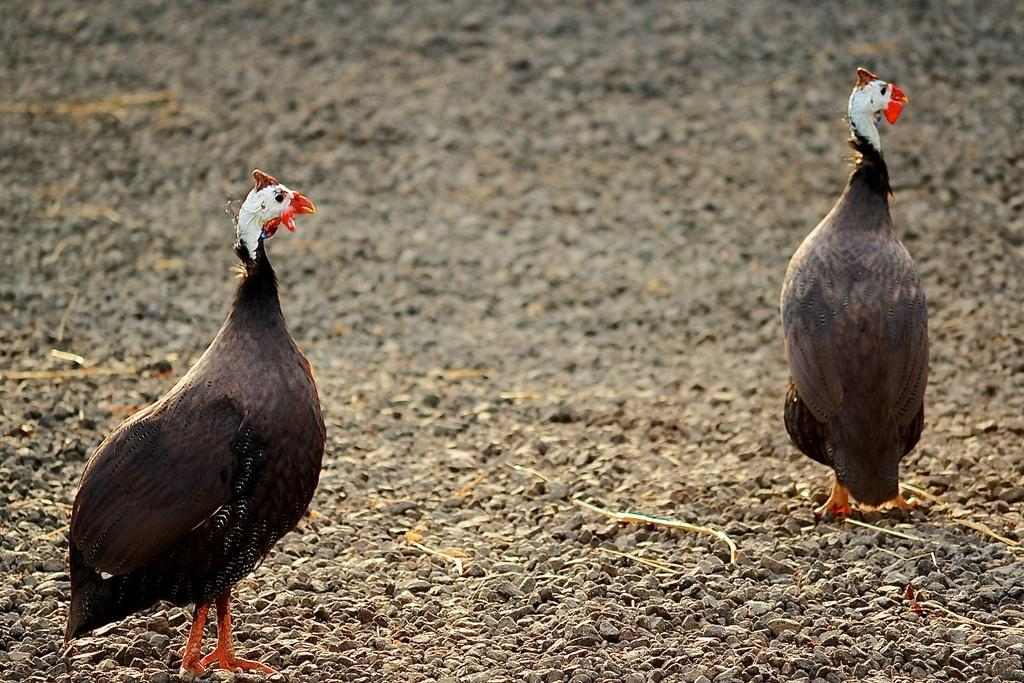What type of birds are in the image? There are two turkey hens in the image. Where are the turkey hens located? The turkey hens are standing on the ground. What else can be seen on the ground in the image? Small stones are visible in the image. How many babies are playing with the button in the image? There are no babies or buttons present in the image. What type of animal is the zebra interacting with the turkey hens in the image? There is no zebra present in the image; it only features two turkey hens. 